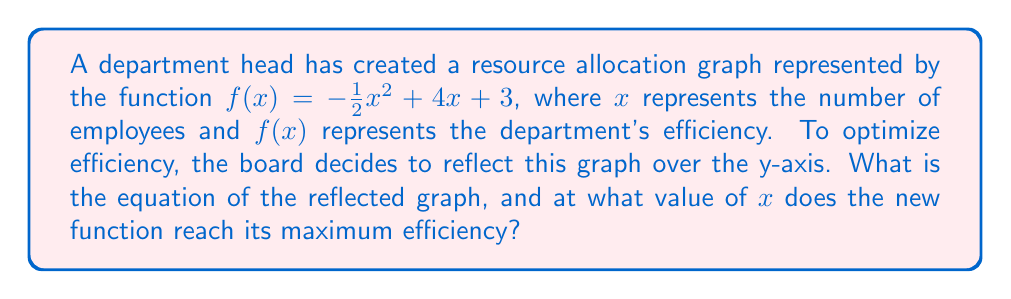Provide a solution to this math problem. 1. To reflect a function over the y-axis, we replace every $x$ with $-x$ in the original function. This gives us:

   $g(x) = -\frac{1}{2}(-x)^2 + 4(-x) + 3$

2. Simplify the squared term:
   $g(x) = -\frac{1}{2}x^2 - 4x + 3$

3. To find the maximum of this parabola, we need to find its vertex. For a quadratic function in the form $ax^2 + bx + c$, the x-coordinate of the vertex is given by $x = -\frac{b}{2a}$.

4. In our case, $a = -\frac{1}{2}$ and $b = -4$. So:

   $x = -\frac{-4}{2(-\frac{1}{2})} = -\frac{-4}{-1} = 4$

5. Therefore, the maximum efficiency of the reflected function occurs at $x = 4$.
Answer: $g(x) = -\frac{1}{2}x^2 - 4x + 3$; Maximum at $x = 4$ 